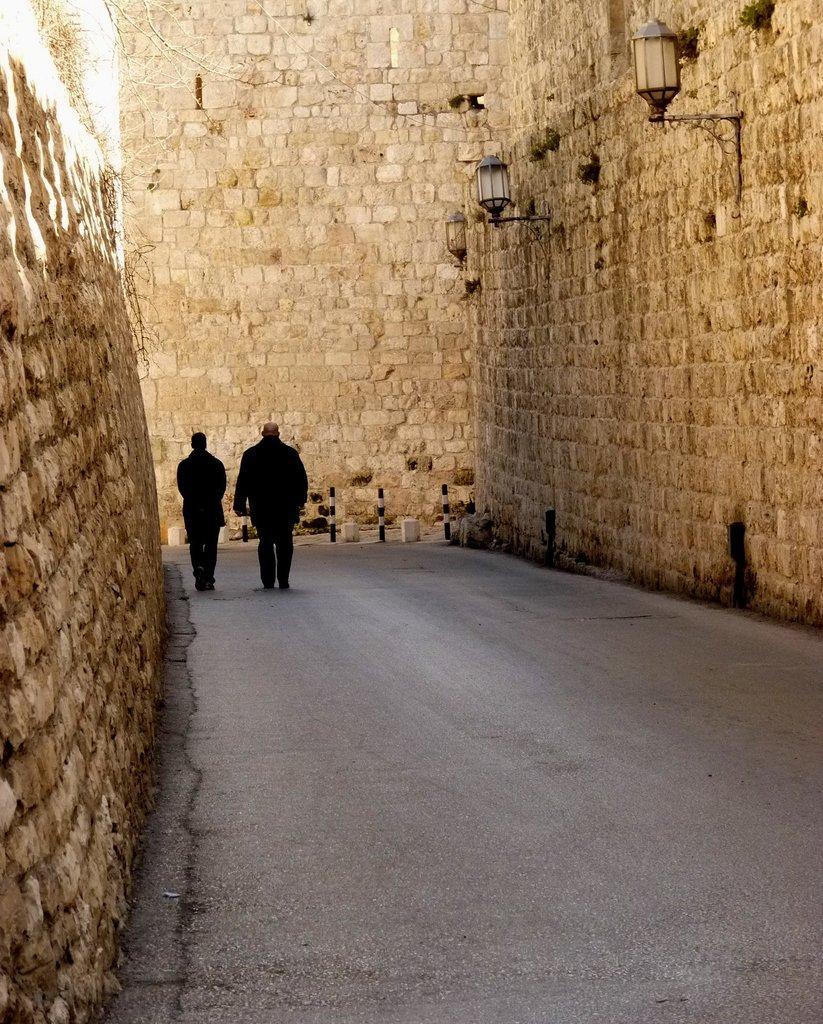Can you describe this image briefly? In this image I can see two people are on the road. These people are wearing the black color dresses. To the side of the people I can see the wall and there are lights to the wall. 